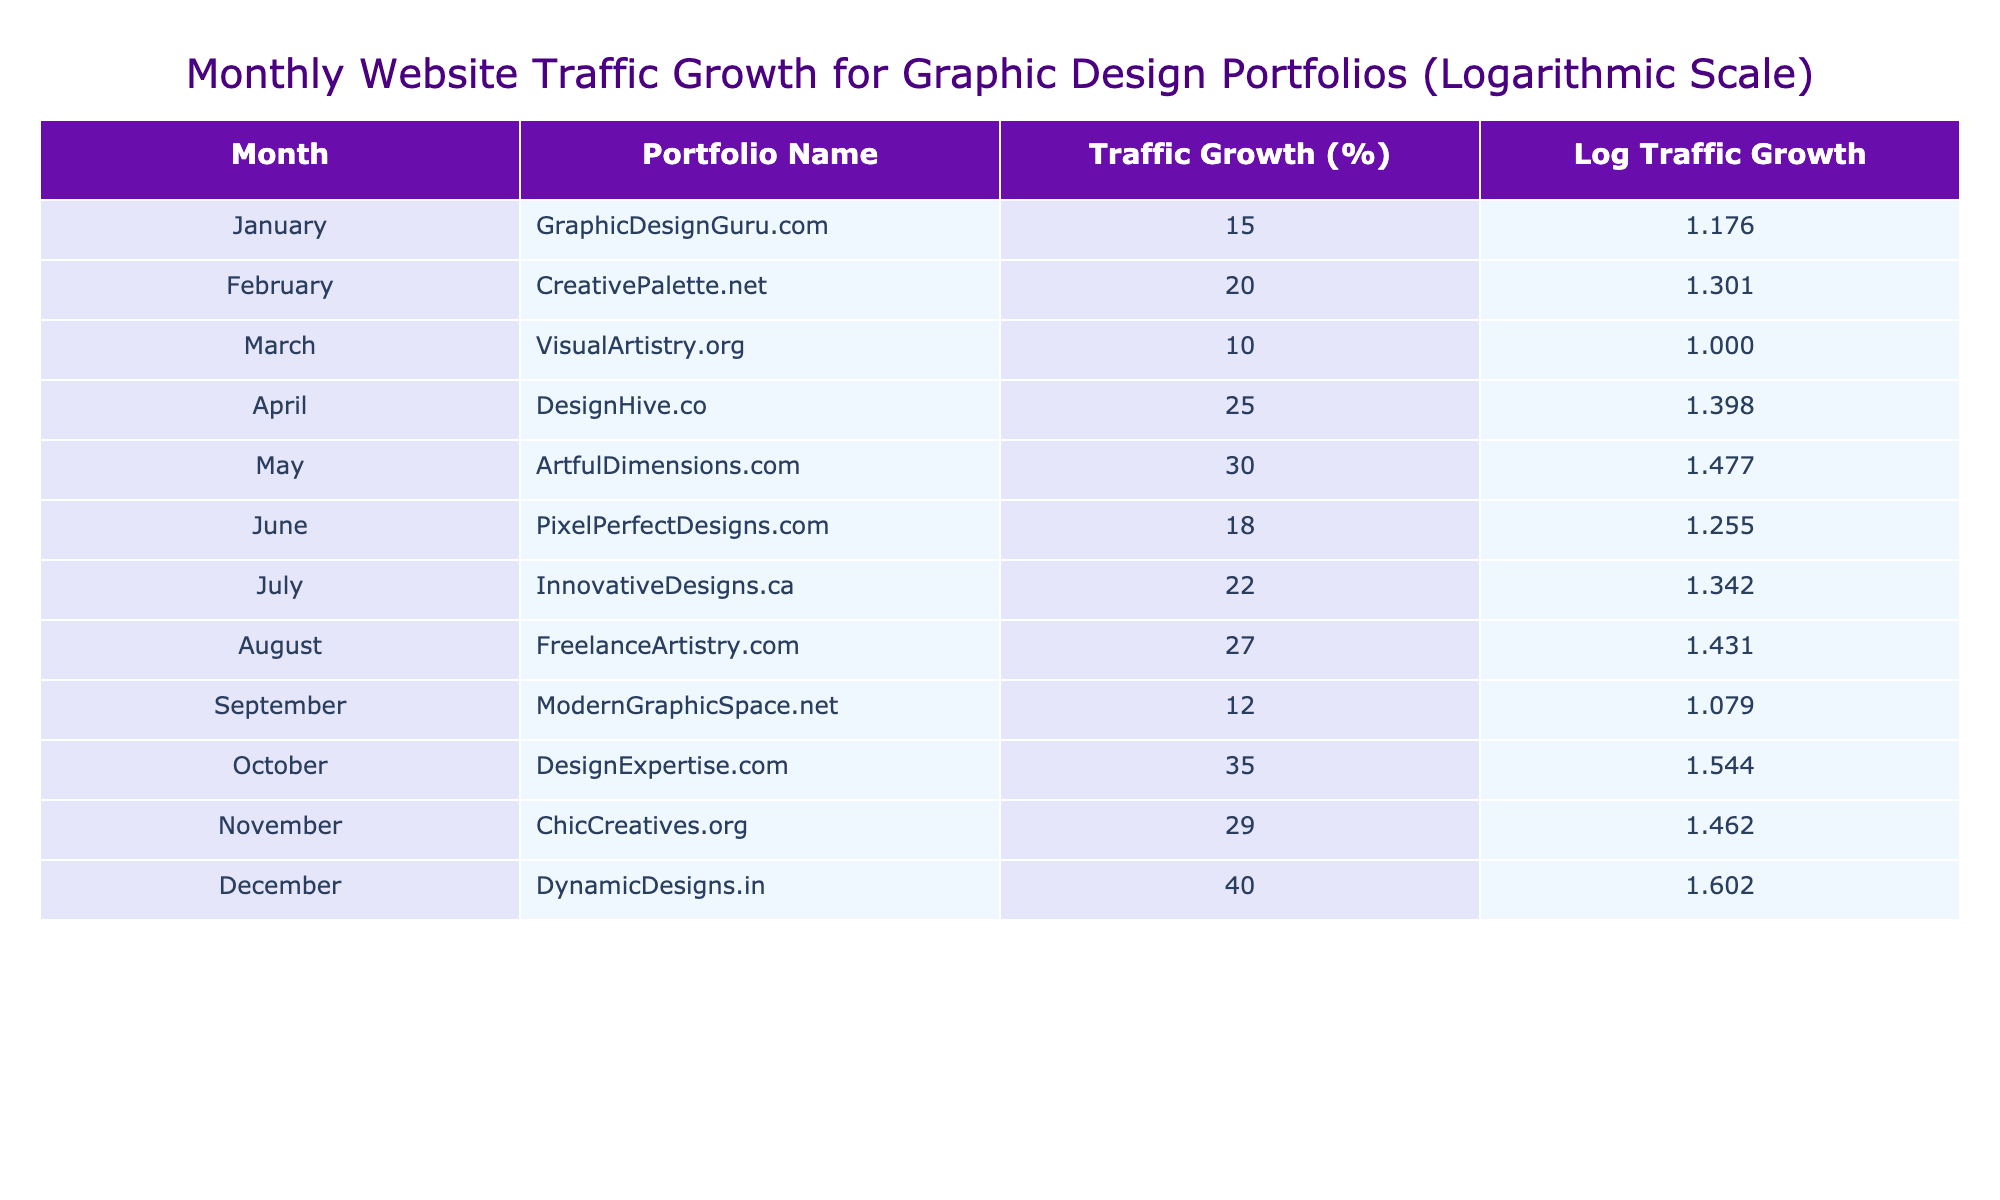What was the website traffic growth percentage for DynamicDesigns.in in December? The table lists December with a website traffic growth of 40%.
Answer: 40 What is the portfolio name with the highest traffic growth percentage? According to the table, DynamicDesigns.in has the highest traffic growth percentage at 40%.
Answer: DynamicDesigns.in What was the average website traffic growth over the twelve months? To find the average, sum all monthly growth percentages: 15 + 20 + 10 + 25 + 30 + 18 + 22 + 27 + 12 + 35 + 29 + 40 =  318. Divide by 12 gives us an average of 318/12 = 26.5.
Answer: 26.5 Did the website traffic ever decrease in any month? The table shows only positive growth percentages for all twelve months, implying no decrease in website traffic.
Answer: No How much higher was the traffic growth percentage in October compared to January? The traffic growth for January is 15% and for October is 35%, thus the difference is 35 - 15 = 20%.
Answer: 20% Which months experienced a traffic growth percentage greater than 25%? By reviewing the table, the months with growth greater than 25% are April (25%), May (30%), August (27%), October (35%), November (29%), and December (40%). Thus, April is not included as it is exactly 25%.
Answer: May, August, October, November, December What is the sum of the website traffic growth percentages for the first half of the year (January to June)? Adding up the traffic growth for the first half: 15 (Jan) + 20 (Feb) + 10 (Mar) + 25 (Apr) + 30 (May) + 18 (Jun) = 118%.
Answer: 118 In which month was the traffic growth percentage 18%? Referring to the table, the month with a traffic growth of 18% is June.
Answer: June How many portfolios had a traffic growth percentage below 20%? The months with growth below 20% are January (15%), March (10%), and June (18%). Thus, there are three portfolios below 20%.
Answer: 3 